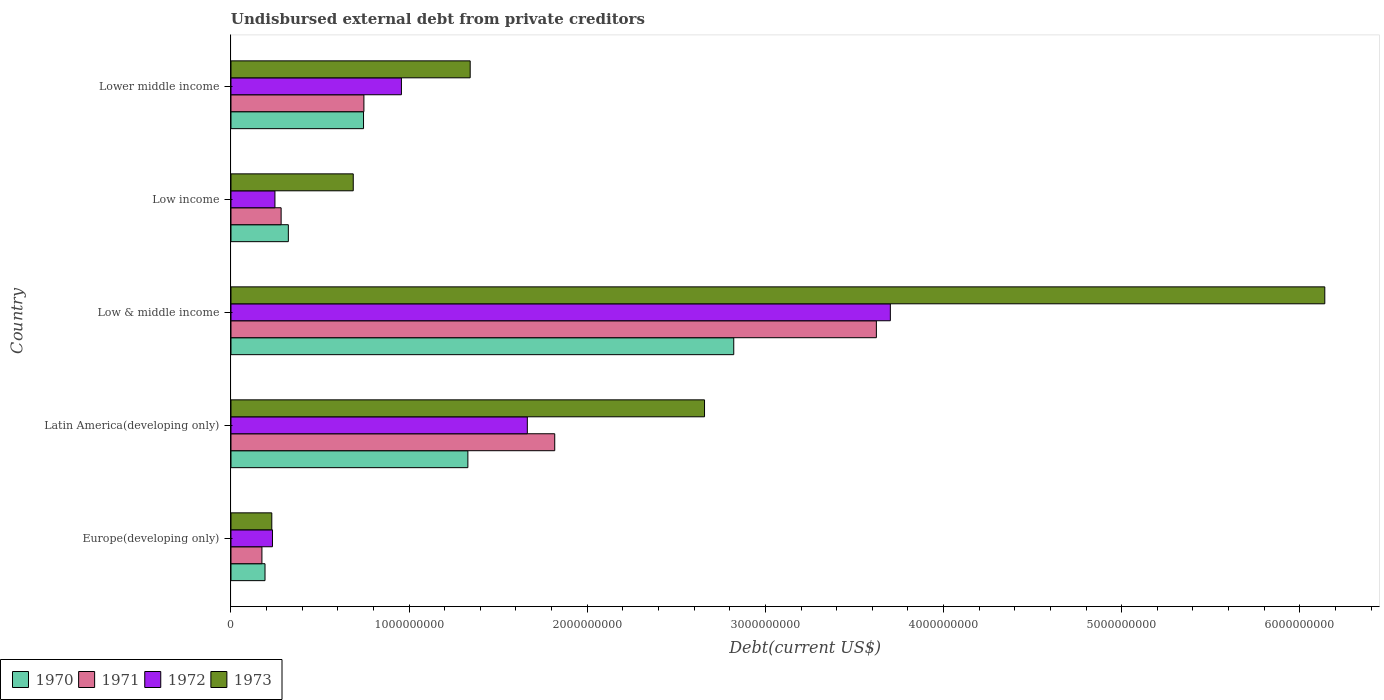How many groups of bars are there?
Provide a short and direct response. 5. Are the number of bars on each tick of the Y-axis equal?
Provide a succinct answer. Yes. How many bars are there on the 4th tick from the top?
Your answer should be very brief. 4. What is the label of the 5th group of bars from the top?
Provide a succinct answer. Europe(developing only). What is the total debt in 1972 in Latin America(developing only)?
Make the answer very short. 1.66e+09. Across all countries, what is the maximum total debt in 1972?
Ensure brevity in your answer.  3.70e+09. Across all countries, what is the minimum total debt in 1971?
Give a very brief answer. 1.74e+08. In which country was the total debt in 1972 minimum?
Your answer should be very brief. Europe(developing only). What is the total total debt in 1972 in the graph?
Your answer should be very brief. 6.80e+09. What is the difference between the total debt in 1972 in Europe(developing only) and that in Latin America(developing only)?
Offer a very short reply. -1.43e+09. What is the difference between the total debt in 1970 in Europe(developing only) and the total debt in 1971 in Low & middle income?
Provide a succinct answer. -3.43e+09. What is the average total debt in 1970 per country?
Provide a succinct answer. 1.08e+09. What is the difference between the total debt in 1970 and total debt in 1972 in Low & middle income?
Offer a very short reply. -8.79e+08. What is the ratio of the total debt in 1970 in Low & middle income to that in Low income?
Give a very brief answer. 8.76. What is the difference between the highest and the second highest total debt in 1973?
Ensure brevity in your answer.  3.48e+09. What is the difference between the highest and the lowest total debt in 1970?
Provide a short and direct response. 2.63e+09. Is it the case that in every country, the sum of the total debt in 1973 and total debt in 1970 is greater than the sum of total debt in 1972 and total debt in 1971?
Your answer should be compact. No. What does the 1st bar from the bottom in Low income represents?
Your answer should be very brief. 1970. Is it the case that in every country, the sum of the total debt in 1972 and total debt in 1973 is greater than the total debt in 1970?
Give a very brief answer. Yes. How many bars are there?
Offer a very short reply. 20. Are all the bars in the graph horizontal?
Your response must be concise. Yes. How many countries are there in the graph?
Your response must be concise. 5. Does the graph contain grids?
Your answer should be very brief. No. How many legend labels are there?
Your response must be concise. 4. What is the title of the graph?
Keep it short and to the point. Undisbursed external debt from private creditors. What is the label or title of the X-axis?
Provide a short and direct response. Debt(current US$). What is the Debt(current US$) in 1970 in Europe(developing only)?
Provide a short and direct response. 1.91e+08. What is the Debt(current US$) of 1971 in Europe(developing only)?
Ensure brevity in your answer.  1.74e+08. What is the Debt(current US$) of 1972 in Europe(developing only)?
Your answer should be very brief. 2.33e+08. What is the Debt(current US$) in 1973 in Europe(developing only)?
Offer a terse response. 2.29e+08. What is the Debt(current US$) in 1970 in Latin America(developing only)?
Offer a very short reply. 1.33e+09. What is the Debt(current US$) of 1971 in Latin America(developing only)?
Your answer should be very brief. 1.82e+09. What is the Debt(current US$) in 1972 in Latin America(developing only)?
Your response must be concise. 1.66e+09. What is the Debt(current US$) of 1973 in Latin America(developing only)?
Ensure brevity in your answer.  2.66e+09. What is the Debt(current US$) in 1970 in Low & middle income?
Your answer should be compact. 2.82e+09. What is the Debt(current US$) in 1971 in Low & middle income?
Keep it short and to the point. 3.62e+09. What is the Debt(current US$) in 1972 in Low & middle income?
Your answer should be very brief. 3.70e+09. What is the Debt(current US$) in 1973 in Low & middle income?
Your response must be concise. 6.14e+09. What is the Debt(current US$) in 1970 in Low income?
Your answer should be very brief. 3.22e+08. What is the Debt(current US$) in 1971 in Low income?
Ensure brevity in your answer.  2.82e+08. What is the Debt(current US$) of 1972 in Low income?
Your answer should be compact. 2.47e+08. What is the Debt(current US$) in 1973 in Low income?
Your answer should be compact. 6.86e+08. What is the Debt(current US$) of 1970 in Lower middle income?
Keep it short and to the point. 7.44e+08. What is the Debt(current US$) of 1971 in Lower middle income?
Provide a short and direct response. 7.46e+08. What is the Debt(current US$) in 1972 in Lower middle income?
Ensure brevity in your answer.  9.57e+08. What is the Debt(current US$) of 1973 in Lower middle income?
Provide a succinct answer. 1.34e+09. Across all countries, what is the maximum Debt(current US$) of 1970?
Your answer should be very brief. 2.82e+09. Across all countries, what is the maximum Debt(current US$) of 1971?
Offer a terse response. 3.62e+09. Across all countries, what is the maximum Debt(current US$) in 1972?
Your response must be concise. 3.70e+09. Across all countries, what is the maximum Debt(current US$) of 1973?
Your answer should be compact. 6.14e+09. Across all countries, what is the minimum Debt(current US$) of 1970?
Your answer should be compact. 1.91e+08. Across all countries, what is the minimum Debt(current US$) in 1971?
Keep it short and to the point. 1.74e+08. Across all countries, what is the minimum Debt(current US$) of 1972?
Your answer should be very brief. 2.33e+08. Across all countries, what is the minimum Debt(current US$) of 1973?
Offer a very short reply. 2.29e+08. What is the total Debt(current US$) of 1970 in the graph?
Offer a very short reply. 5.41e+09. What is the total Debt(current US$) in 1971 in the graph?
Make the answer very short. 6.64e+09. What is the total Debt(current US$) of 1972 in the graph?
Your response must be concise. 6.80e+09. What is the total Debt(current US$) in 1973 in the graph?
Offer a terse response. 1.11e+1. What is the difference between the Debt(current US$) of 1970 in Europe(developing only) and that in Latin America(developing only)?
Give a very brief answer. -1.14e+09. What is the difference between the Debt(current US$) of 1971 in Europe(developing only) and that in Latin America(developing only)?
Your answer should be very brief. -1.64e+09. What is the difference between the Debt(current US$) of 1972 in Europe(developing only) and that in Latin America(developing only)?
Your response must be concise. -1.43e+09. What is the difference between the Debt(current US$) of 1973 in Europe(developing only) and that in Latin America(developing only)?
Offer a terse response. -2.43e+09. What is the difference between the Debt(current US$) of 1970 in Europe(developing only) and that in Low & middle income?
Your answer should be very brief. -2.63e+09. What is the difference between the Debt(current US$) in 1971 in Europe(developing only) and that in Low & middle income?
Keep it short and to the point. -3.45e+09. What is the difference between the Debt(current US$) of 1972 in Europe(developing only) and that in Low & middle income?
Keep it short and to the point. -3.47e+09. What is the difference between the Debt(current US$) of 1973 in Europe(developing only) and that in Low & middle income?
Your response must be concise. -5.91e+09. What is the difference between the Debt(current US$) in 1970 in Europe(developing only) and that in Low income?
Your response must be concise. -1.31e+08. What is the difference between the Debt(current US$) in 1971 in Europe(developing only) and that in Low income?
Your response must be concise. -1.08e+08. What is the difference between the Debt(current US$) in 1972 in Europe(developing only) and that in Low income?
Your answer should be very brief. -1.39e+07. What is the difference between the Debt(current US$) in 1973 in Europe(developing only) and that in Low income?
Keep it short and to the point. -4.57e+08. What is the difference between the Debt(current US$) of 1970 in Europe(developing only) and that in Lower middle income?
Keep it short and to the point. -5.53e+08. What is the difference between the Debt(current US$) of 1971 in Europe(developing only) and that in Lower middle income?
Provide a succinct answer. -5.73e+08. What is the difference between the Debt(current US$) in 1972 in Europe(developing only) and that in Lower middle income?
Offer a very short reply. -7.24e+08. What is the difference between the Debt(current US$) of 1973 in Europe(developing only) and that in Lower middle income?
Keep it short and to the point. -1.11e+09. What is the difference between the Debt(current US$) of 1970 in Latin America(developing only) and that in Low & middle income?
Offer a terse response. -1.49e+09. What is the difference between the Debt(current US$) of 1971 in Latin America(developing only) and that in Low & middle income?
Your answer should be very brief. -1.81e+09. What is the difference between the Debt(current US$) in 1972 in Latin America(developing only) and that in Low & middle income?
Your answer should be very brief. -2.04e+09. What is the difference between the Debt(current US$) of 1973 in Latin America(developing only) and that in Low & middle income?
Offer a very short reply. -3.48e+09. What is the difference between the Debt(current US$) in 1970 in Latin America(developing only) and that in Low income?
Give a very brief answer. 1.01e+09. What is the difference between the Debt(current US$) in 1971 in Latin America(developing only) and that in Low income?
Your answer should be compact. 1.54e+09. What is the difference between the Debt(current US$) of 1972 in Latin America(developing only) and that in Low income?
Your response must be concise. 1.42e+09. What is the difference between the Debt(current US$) of 1973 in Latin America(developing only) and that in Low income?
Offer a terse response. 1.97e+09. What is the difference between the Debt(current US$) of 1970 in Latin America(developing only) and that in Lower middle income?
Your answer should be very brief. 5.86e+08. What is the difference between the Debt(current US$) of 1971 in Latin America(developing only) and that in Lower middle income?
Keep it short and to the point. 1.07e+09. What is the difference between the Debt(current US$) in 1972 in Latin America(developing only) and that in Lower middle income?
Your answer should be compact. 7.07e+08. What is the difference between the Debt(current US$) of 1973 in Latin America(developing only) and that in Lower middle income?
Make the answer very short. 1.32e+09. What is the difference between the Debt(current US$) in 1970 in Low & middle income and that in Low income?
Your answer should be very brief. 2.50e+09. What is the difference between the Debt(current US$) of 1971 in Low & middle income and that in Low income?
Offer a very short reply. 3.34e+09. What is the difference between the Debt(current US$) of 1972 in Low & middle income and that in Low income?
Your answer should be very brief. 3.45e+09. What is the difference between the Debt(current US$) of 1973 in Low & middle income and that in Low income?
Ensure brevity in your answer.  5.45e+09. What is the difference between the Debt(current US$) of 1970 in Low & middle income and that in Lower middle income?
Offer a very short reply. 2.08e+09. What is the difference between the Debt(current US$) of 1971 in Low & middle income and that in Lower middle income?
Keep it short and to the point. 2.88e+09. What is the difference between the Debt(current US$) in 1972 in Low & middle income and that in Lower middle income?
Your answer should be very brief. 2.74e+09. What is the difference between the Debt(current US$) in 1973 in Low & middle income and that in Lower middle income?
Provide a short and direct response. 4.80e+09. What is the difference between the Debt(current US$) in 1970 in Low income and that in Lower middle income?
Make the answer very short. -4.22e+08. What is the difference between the Debt(current US$) in 1971 in Low income and that in Lower middle income?
Your response must be concise. -4.65e+08. What is the difference between the Debt(current US$) in 1972 in Low income and that in Lower middle income?
Keep it short and to the point. -7.10e+08. What is the difference between the Debt(current US$) of 1973 in Low income and that in Lower middle income?
Your answer should be compact. -6.56e+08. What is the difference between the Debt(current US$) in 1970 in Europe(developing only) and the Debt(current US$) in 1971 in Latin America(developing only)?
Keep it short and to the point. -1.63e+09. What is the difference between the Debt(current US$) of 1970 in Europe(developing only) and the Debt(current US$) of 1972 in Latin America(developing only)?
Make the answer very short. -1.47e+09. What is the difference between the Debt(current US$) in 1970 in Europe(developing only) and the Debt(current US$) in 1973 in Latin America(developing only)?
Offer a terse response. -2.47e+09. What is the difference between the Debt(current US$) of 1971 in Europe(developing only) and the Debt(current US$) of 1972 in Latin America(developing only)?
Give a very brief answer. -1.49e+09. What is the difference between the Debt(current US$) in 1971 in Europe(developing only) and the Debt(current US$) in 1973 in Latin America(developing only)?
Your answer should be compact. -2.48e+09. What is the difference between the Debt(current US$) in 1972 in Europe(developing only) and the Debt(current US$) in 1973 in Latin America(developing only)?
Provide a short and direct response. -2.43e+09. What is the difference between the Debt(current US$) in 1970 in Europe(developing only) and the Debt(current US$) in 1971 in Low & middle income?
Ensure brevity in your answer.  -3.43e+09. What is the difference between the Debt(current US$) in 1970 in Europe(developing only) and the Debt(current US$) in 1972 in Low & middle income?
Make the answer very short. -3.51e+09. What is the difference between the Debt(current US$) in 1970 in Europe(developing only) and the Debt(current US$) in 1973 in Low & middle income?
Keep it short and to the point. -5.95e+09. What is the difference between the Debt(current US$) of 1971 in Europe(developing only) and the Debt(current US$) of 1972 in Low & middle income?
Your answer should be compact. -3.53e+09. What is the difference between the Debt(current US$) of 1971 in Europe(developing only) and the Debt(current US$) of 1973 in Low & middle income?
Keep it short and to the point. -5.97e+09. What is the difference between the Debt(current US$) of 1972 in Europe(developing only) and the Debt(current US$) of 1973 in Low & middle income?
Your answer should be compact. -5.91e+09. What is the difference between the Debt(current US$) of 1970 in Europe(developing only) and the Debt(current US$) of 1971 in Low income?
Provide a succinct answer. -9.05e+07. What is the difference between the Debt(current US$) in 1970 in Europe(developing only) and the Debt(current US$) in 1972 in Low income?
Offer a very short reply. -5.58e+07. What is the difference between the Debt(current US$) in 1970 in Europe(developing only) and the Debt(current US$) in 1973 in Low income?
Provide a short and direct response. -4.95e+08. What is the difference between the Debt(current US$) of 1971 in Europe(developing only) and the Debt(current US$) of 1972 in Low income?
Ensure brevity in your answer.  -7.31e+07. What is the difference between the Debt(current US$) in 1971 in Europe(developing only) and the Debt(current US$) in 1973 in Low income?
Ensure brevity in your answer.  -5.13e+08. What is the difference between the Debt(current US$) in 1972 in Europe(developing only) and the Debt(current US$) in 1973 in Low income?
Provide a short and direct response. -4.54e+08. What is the difference between the Debt(current US$) of 1970 in Europe(developing only) and the Debt(current US$) of 1971 in Lower middle income?
Your answer should be very brief. -5.55e+08. What is the difference between the Debt(current US$) of 1970 in Europe(developing only) and the Debt(current US$) of 1972 in Lower middle income?
Offer a terse response. -7.66e+08. What is the difference between the Debt(current US$) in 1970 in Europe(developing only) and the Debt(current US$) in 1973 in Lower middle income?
Your answer should be very brief. -1.15e+09. What is the difference between the Debt(current US$) of 1971 in Europe(developing only) and the Debt(current US$) of 1972 in Lower middle income?
Provide a short and direct response. -7.83e+08. What is the difference between the Debt(current US$) of 1971 in Europe(developing only) and the Debt(current US$) of 1973 in Lower middle income?
Ensure brevity in your answer.  -1.17e+09. What is the difference between the Debt(current US$) in 1972 in Europe(developing only) and the Debt(current US$) in 1973 in Lower middle income?
Keep it short and to the point. -1.11e+09. What is the difference between the Debt(current US$) of 1970 in Latin America(developing only) and the Debt(current US$) of 1971 in Low & middle income?
Ensure brevity in your answer.  -2.29e+09. What is the difference between the Debt(current US$) of 1970 in Latin America(developing only) and the Debt(current US$) of 1972 in Low & middle income?
Offer a very short reply. -2.37e+09. What is the difference between the Debt(current US$) in 1970 in Latin America(developing only) and the Debt(current US$) in 1973 in Low & middle income?
Ensure brevity in your answer.  -4.81e+09. What is the difference between the Debt(current US$) of 1971 in Latin America(developing only) and the Debt(current US$) of 1972 in Low & middle income?
Keep it short and to the point. -1.88e+09. What is the difference between the Debt(current US$) in 1971 in Latin America(developing only) and the Debt(current US$) in 1973 in Low & middle income?
Provide a short and direct response. -4.32e+09. What is the difference between the Debt(current US$) in 1972 in Latin America(developing only) and the Debt(current US$) in 1973 in Low & middle income?
Your answer should be compact. -4.48e+09. What is the difference between the Debt(current US$) in 1970 in Latin America(developing only) and the Debt(current US$) in 1971 in Low income?
Keep it short and to the point. 1.05e+09. What is the difference between the Debt(current US$) of 1970 in Latin America(developing only) and the Debt(current US$) of 1972 in Low income?
Ensure brevity in your answer.  1.08e+09. What is the difference between the Debt(current US$) in 1970 in Latin America(developing only) and the Debt(current US$) in 1973 in Low income?
Give a very brief answer. 6.43e+08. What is the difference between the Debt(current US$) of 1971 in Latin America(developing only) and the Debt(current US$) of 1972 in Low income?
Your answer should be very brief. 1.57e+09. What is the difference between the Debt(current US$) in 1971 in Latin America(developing only) and the Debt(current US$) in 1973 in Low income?
Your answer should be compact. 1.13e+09. What is the difference between the Debt(current US$) of 1972 in Latin America(developing only) and the Debt(current US$) of 1973 in Low income?
Offer a terse response. 9.77e+08. What is the difference between the Debt(current US$) in 1970 in Latin America(developing only) and the Debt(current US$) in 1971 in Lower middle income?
Give a very brief answer. 5.84e+08. What is the difference between the Debt(current US$) of 1970 in Latin America(developing only) and the Debt(current US$) of 1972 in Lower middle income?
Give a very brief answer. 3.73e+08. What is the difference between the Debt(current US$) in 1970 in Latin America(developing only) and the Debt(current US$) in 1973 in Lower middle income?
Keep it short and to the point. -1.29e+07. What is the difference between the Debt(current US$) in 1971 in Latin America(developing only) and the Debt(current US$) in 1972 in Lower middle income?
Offer a terse response. 8.61e+08. What is the difference between the Debt(current US$) of 1971 in Latin America(developing only) and the Debt(current US$) of 1973 in Lower middle income?
Ensure brevity in your answer.  4.75e+08. What is the difference between the Debt(current US$) of 1972 in Latin America(developing only) and the Debt(current US$) of 1973 in Lower middle income?
Provide a short and direct response. 3.21e+08. What is the difference between the Debt(current US$) of 1970 in Low & middle income and the Debt(current US$) of 1971 in Low income?
Make the answer very short. 2.54e+09. What is the difference between the Debt(current US$) in 1970 in Low & middle income and the Debt(current US$) in 1972 in Low income?
Keep it short and to the point. 2.58e+09. What is the difference between the Debt(current US$) of 1970 in Low & middle income and the Debt(current US$) of 1973 in Low income?
Ensure brevity in your answer.  2.14e+09. What is the difference between the Debt(current US$) of 1971 in Low & middle income and the Debt(current US$) of 1972 in Low income?
Offer a terse response. 3.38e+09. What is the difference between the Debt(current US$) of 1971 in Low & middle income and the Debt(current US$) of 1973 in Low income?
Offer a very short reply. 2.94e+09. What is the difference between the Debt(current US$) in 1972 in Low & middle income and the Debt(current US$) in 1973 in Low income?
Provide a succinct answer. 3.02e+09. What is the difference between the Debt(current US$) of 1970 in Low & middle income and the Debt(current US$) of 1971 in Lower middle income?
Your answer should be very brief. 2.08e+09. What is the difference between the Debt(current US$) of 1970 in Low & middle income and the Debt(current US$) of 1972 in Lower middle income?
Your response must be concise. 1.87e+09. What is the difference between the Debt(current US$) of 1970 in Low & middle income and the Debt(current US$) of 1973 in Lower middle income?
Offer a terse response. 1.48e+09. What is the difference between the Debt(current US$) in 1971 in Low & middle income and the Debt(current US$) in 1972 in Lower middle income?
Offer a very short reply. 2.67e+09. What is the difference between the Debt(current US$) of 1971 in Low & middle income and the Debt(current US$) of 1973 in Lower middle income?
Make the answer very short. 2.28e+09. What is the difference between the Debt(current US$) in 1972 in Low & middle income and the Debt(current US$) in 1973 in Lower middle income?
Offer a very short reply. 2.36e+09. What is the difference between the Debt(current US$) of 1970 in Low income and the Debt(current US$) of 1971 in Lower middle income?
Offer a terse response. -4.24e+08. What is the difference between the Debt(current US$) in 1970 in Low income and the Debt(current US$) in 1972 in Lower middle income?
Give a very brief answer. -6.35e+08. What is the difference between the Debt(current US$) in 1970 in Low income and the Debt(current US$) in 1973 in Lower middle income?
Your answer should be compact. -1.02e+09. What is the difference between the Debt(current US$) in 1971 in Low income and the Debt(current US$) in 1972 in Lower middle income?
Your response must be concise. -6.75e+08. What is the difference between the Debt(current US$) of 1971 in Low income and the Debt(current US$) of 1973 in Lower middle income?
Make the answer very short. -1.06e+09. What is the difference between the Debt(current US$) of 1972 in Low income and the Debt(current US$) of 1973 in Lower middle income?
Give a very brief answer. -1.10e+09. What is the average Debt(current US$) of 1970 per country?
Make the answer very short. 1.08e+09. What is the average Debt(current US$) of 1971 per country?
Provide a succinct answer. 1.33e+09. What is the average Debt(current US$) of 1972 per country?
Keep it short and to the point. 1.36e+09. What is the average Debt(current US$) in 1973 per country?
Keep it short and to the point. 2.21e+09. What is the difference between the Debt(current US$) in 1970 and Debt(current US$) in 1971 in Europe(developing only)?
Provide a succinct answer. 1.74e+07. What is the difference between the Debt(current US$) in 1970 and Debt(current US$) in 1972 in Europe(developing only)?
Your answer should be compact. -4.19e+07. What is the difference between the Debt(current US$) of 1970 and Debt(current US$) of 1973 in Europe(developing only)?
Your answer should be very brief. -3.81e+07. What is the difference between the Debt(current US$) in 1971 and Debt(current US$) in 1972 in Europe(developing only)?
Make the answer very short. -5.92e+07. What is the difference between the Debt(current US$) of 1971 and Debt(current US$) of 1973 in Europe(developing only)?
Your response must be concise. -5.55e+07. What is the difference between the Debt(current US$) of 1972 and Debt(current US$) of 1973 in Europe(developing only)?
Make the answer very short. 3.73e+06. What is the difference between the Debt(current US$) of 1970 and Debt(current US$) of 1971 in Latin America(developing only)?
Your response must be concise. -4.88e+08. What is the difference between the Debt(current US$) of 1970 and Debt(current US$) of 1972 in Latin America(developing only)?
Offer a very short reply. -3.34e+08. What is the difference between the Debt(current US$) in 1970 and Debt(current US$) in 1973 in Latin America(developing only)?
Offer a very short reply. -1.33e+09. What is the difference between the Debt(current US$) in 1971 and Debt(current US$) in 1972 in Latin America(developing only)?
Make the answer very short. 1.54e+08. What is the difference between the Debt(current US$) in 1971 and Debt(current US$) in 1973 in Latin America(developing only)?
Your response must be concise. -8.41e+08. What is the difference between the Debt(current US$) in 1972 and Debt(current US$) in 1973 in Latin America(developing only)?
Your answer should be very brief. -9.95e+08. What is the difference between the Debt(current US$) of 1970 and Debt(current US$) of 1971 in Low & middle income?
Your answer should be very brief. -8.01e+08. What is the difference between the Debt(current US$) of 1970 and Debt(current US$) of 1972 in Low & middle income?
Ensure brevity in your answer.  -8.79e+08. What is the difference between the Debt(current US$) of 1970 and Debt(current US$) of 1973 in Low & middle income?
Offer a terse response. -3.32e+09. What is the difference between the Debt(current US$) in 1971 and Debt(current US$) in 1972 in Low & middle income?
Provide a succinct answer. -7.84e+07. What is the difference between the Debt(current US$) in 1971 and Debt(current US$) in 1973 in Low & middle income?
Provide a short and direct response. -2.52e+09. What is the difference between the Debt(current US$) of 1972 and Debt(current US$) of 1973 in Low & middle income?
Make the answer very short. -2.44e+09. What is the difference between the Debt(current US$) of 1970 and Debt(current US$) of 1971 in Low income?
Offer a very short reply. 4.06e+07. What is the difference between the Debt(current US$) in 1970 and Debt(current US$) in 1972 in Low income?
Provide a short and direct response. 7.53e+07. What is the difference between the Debt(current US$) of 1970 and Debt(current US$) of 1973 in Low income?
Ensure brevity in your answer.  -3.64e+08. What is the difference between the Debt(current US$) of 1971 and Debt(current US$) of 1972 in Low income?
Give a very brief answer. 3.47e+07. What is the difference between the Debt(current US$) of 1971 and Debt(current US$) of 1973 in Low income?
Keep it short and to the point. -4.05e+08. What is the difference between the Debt(current US$) of 1972 and Debt(current US$) of 1973 in Low income?
Your response must be concise. -4.40e+08. What is the difference between the Debt(current US$) in 1970 and Debt(current US$) in 1971 in Lower middle income?
Keep it short and to the point. -2.10e+06. What is the difference between the Debt(current US$) in 1970 and Debt(current US$) in 1972 in Lower middle income?
Offer a terse response. -2.13e+08. What is the difference between the Debt(current US$) in 1970 and Debt(current US$) in 1973 in Lower middle income?
Provide a short and direct response. -5.99e+08. What is the difference between the Debt(current US$) of 1971 and Debt(current US$) of 1972 in Lower middle income?
Your response must be concise. -2.11e+08. What is the difference between the Debt(current US$) in 1971 and Debt(current US$) in 1973 in Lower middle income?
Keep it short and to the point. -5.97e+08. What is the difference between the Debt(current US$) in 1972 and Debt(current US$) in 1973 in Lower middle income?
Your answer should be compact. -3.86e+08. What is the ratio of the Debt(current US$) in 1970 in Europe(developing only) to that in Latin America(developing only)?
Make the answer very short. 0.14. What is the ratio of the Debt(current US$) of 1971 in Europe(developing only) to that in Latin America(developing only)?
Your answer should be compact. 0.1. What is the ratio of the Debt(current US$) of 1972 in Europe(developing only) to that in Latin America(developing only)?
Give a very brief answer. 0.14. What is the ratio of the Debt(current US$) in 1973 in Europe(developing only) to that in Latin America(developing only)?
Your response must be concise. 0.09. What is the ratio of the Debt(current US$) in 1970 in Europe(developing only) to that in Low & middle income?
Give a very brief answer. 0.07. What is the ratio of the Debt(current US$) of 1971 in Europe(developing only) to that in Low & middle income?
Keep it short and to the point. 0.05. What is the ratio of the Debt(current US$) of 1972 in Europe(developing only) to that in Low & middle income?
Your answer should be compact. 0.06. What is the ratio of the Debt(current US$) in 1973 in Europe(developing only) to that in Low & middle income?
Give a very brief answer. 0.04. What is the ratio of the Debt(current US$) of 1970 in Europe(developing only) to that in Low income?
Offer a terse response. 0.59. What is the ratio of the Debt(current US$) of 1971 in Europe(developing only) to that in Low income?
Give a very brief answer. 0.62. What is the ratio of the Debt(current US$) in 1972 in Europe(developing only) to that in Low income?
Ensure brevity in your answer.  0.94. What is the ratio of the Debt(current US$) of 1973 in Europe(developing only) to that in Low income?
Make the answer very short. 0.33. What is the ratio of the Debt(current US$) of 1970 in Europe(developing only) to that in Lower middle income?
Your response must be concise. 0.26. What is the ratio of the Debt(current US$) in 1971 in Europe(developing only) to that in Lower middle income?
Offer a very short reply. 0.23. What is the ratio of the Debt(current US$) of 1972 in Europe(developing only) to that in Lower middle income?
Provide a succinct answer. 0.24. What is the ratio of the Debt(current US$) in 1973 in Europe(developing only) to that in Lower middle income?
Provide a short and direct response. 0.17. What is the ratio of the Debt(current US$) in 1970 in Latin America(developing only) to that in Low & middle income?
Provide a short and direct response. 0.47. What is the ratio of the Debt(current US$) of 1971 in Latin America(developing only) to that in Low & middle income?
Ensure brevity in your answer.  0.5. What is the ratio of the Debt(current US$) in 1972 in Latin America(developing only) to that in Low & middle income?
Your answer should be compact. 0.45. What is the ratio of the Debt(current US$) of 1973 in Latin America(developing only) to that in Low & middle income?
Your answer should be very brief. 0.43. What is the ratio of the Debt(current US$) in 1970 in Latin America(developing only) to that in Low income?
Provide a short and direct response. 4.13. What is the ratio of the Debt(current US$) in 1971 in Latin America(developing only) to that in Low income?
Provide a short and direct response. 6.46. What is the ratio of the Debt(current US$) of 1972 in Latin America(developing only) to that in Low income?
Keep it short and to the point. 6.74. What is the ratio of the Debt(current US$) of 1973 in Latin America(developing only) to that in Low income?
Offer a terse response. 3.87. What is the ratio of the Debt(current US$) in 1970 in Latin America(developing only) to that in Lower middle income?
Provide a succinct answer. 1.79. What is the ratio of the Debt(current US$) of 1971 in Latin America(developing only) to that in Lower middle income?
Your answer should be compact. 2.44. What is the ratio of the Debt(current US$) in 1972 in Latin America(developing only) to that in Lower middle income?
Provide a short and direct response. 1.74. What is the ratio of the Debt(current US$) in 1973 in Latin America(developing only) to that in Lower middle income?
Ensure brevity in your answer.  1.98. What is the ratio of the Debt(current US$) of 1970 in Low & middle income to that in Low income?
Your answer should be compact. 8.76. What is the ratio of the Debt(current US$) of 1971 in Low & middle income to that in Low income?
Offer a very short reply. 12.87. What is the ratio of the Debt(current US$) of 1972 in Low & middle income to that in Low income?
Give a very brief answer. 15. What is the ratio of the Debt(current US$) in 1973 in Low & middle income to that in Low income?
Give a very brief answer. 8.95. What is the ratio of the Debt(current US$) of 1970 in Low & middle income to that in Lower middle income?
Offer a terse response. 3.79. What is the ratio of the Debt(current US$) in 1971 in Low & middle income to that in Lower middle income?
Make the answer very short. 4.86. What is the ratio of the Debt(current US$) in 1972 in Low & middle income to that in Lower middle income?
Provide a short and direct response. 3.87. What is the ratio of the Debt(current US$) of 1973 in Low & middle income to that in Lower middle income?
Your response must be concise. 4.57. What is the ratio of the Debt(current US$) in 1970 in Low income to that in Lower middle income?
Your response must be concise. 0.43. What is the ratio of the Debt(current US$) in 1971 in Low income to that in Lower middle income?
Offer a terse response. 0.38. What is the ratio of the Debt(current US$) of 1972 in Low income to that in Lower middle income?
Your response must be concise. 0.26. What is the ratio of the Debt(current US$) of 1973 in Low income to that in Lower middle income?
Ensure brevity in your answer.  0.51. What is the difference between the highest and the second highest Debt(current US$) in 1970?
Make the answer very short. 1.49e+09. What is the difference between the highest and the second highest Debt(current US$) in 1971?
Keep it short and to the point. 1.81e+09. What is the difference between the highest and the second highest Debt(current US$) of 1972?
Ensure brevity in your answer.  2.04e+09. What is the difference between the highest and the second highest Debt(current US$) of 1973?
Your answer should be very brief. 3.48e+09. What is the difference between the highest and the lowest Debt(current US$) in 1970?
Offer a very short reply. 2.63e+09. What is the difference between the highest and the lowest Debt(current US$) in 1971?
Provide a succinct answer. 3.45e+09. What is the difference between the highest and the lowest Debt(current US$) of 1972?
Your answer should be compact. 3.47e+09. What is the difference between the highest and the lowest Debt(current US$) of 1973?
Give a very brief answer. 5.91e+09. 